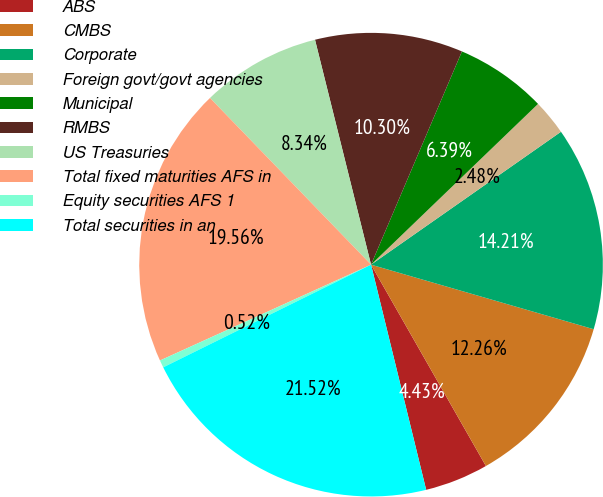Convert chart to OTSL. <chart><loc_0><loc_0><loc_500><loc_500><pie_chart><fcel>ABS<fcel>CMBS<fcel>Corporate<fcel>Foreign govt/govt agencies<fcel>Municipal<fcel>RMBS<fcel>US Treasuries<fcel>Total fixed maturities AFS in<fcel>Equity securities AFS 1<fcel>Total securities in an<nl><fcel>4.43%<fcel>12.26%<fcel>14.21%<fcel>2.48%<fcel>6.39%<fcel>10.3%<fcel>8.34%<fcel>19.56%<fcel>0.52%<fcel>21.52%<nl></chart> 